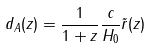Convert formula to latex. <formula><loc_0><loc_0><loc_500><loc_500>d _ { A } ( z ) = \frac { 1 } { 1 + z } \frac { c } { H _ { 0 } } { \tilde { r } } ( z )</formula> 